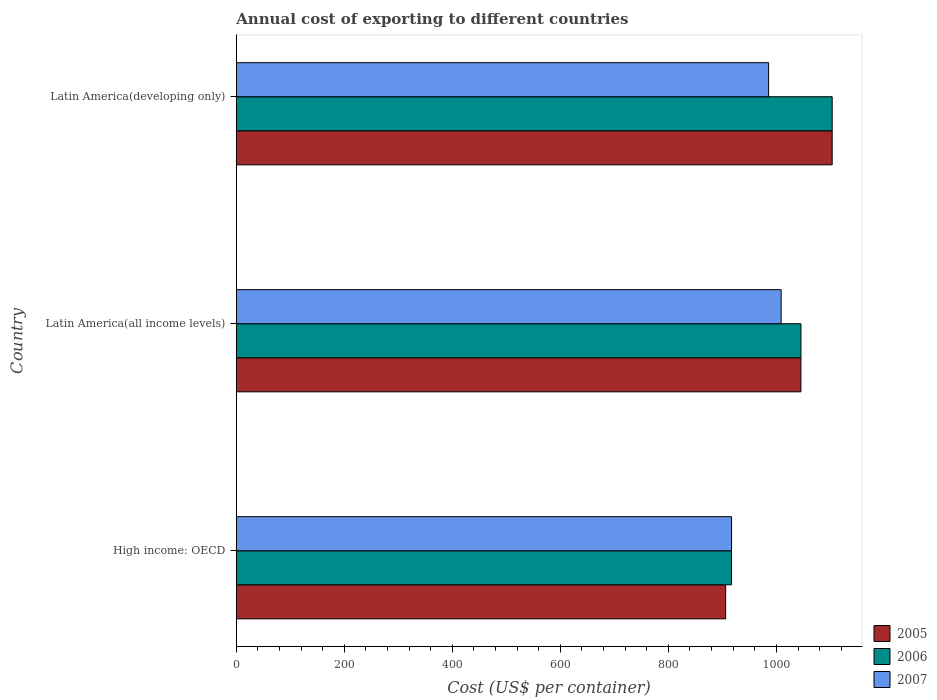Are the number of bars per tick equal to the number of legend labels?
Your answer should be compact. Yes. Are the number of bars on each tick of the Y-axis equal?
Provide a succinct answer. Yes. How many bars are there on the 2nd tick from the bottom?
Keep it short and to the point. 3. What is the label of the 2nd group of bars from the top?
Offer a terse response. Latin America(all income levels). What is the total annual cost of exporting in 2005 in High income: OECD?
Make the answer very short. 906.03. Across all countries, what is the maximum total annual cost of exporting in 2006?
Make the answer very short. 1103.3. Across all countries, what is the minimum total annual cost of exporting in 2007?
Your answer should be very brief. 916.94. In which country was the total annual cost of exporting in 2007 maximum?
Offer a terse response. Latin America(all income levels). In which country was the total annual cost of exporting in 2007 minimum?
Offer a very short reply. High income: OECD. What is the total total annual cost of exporting in 2005 in the graph?
Provide a succinct answer. 3054.71. What is the difference between the total annual cost of exporting in 2007 in High income: OECD and that in Latin America(all income levels)?
Your response must be concise. -91.88. What is the difference between the total annual cost of exporting in 2007 in High income: OECD and the total annual cost of exporting in 2006 in Latin America(developing only)?
Provide a short and direct response. -186.37. What is the average total annual cost of exporting in 2005 per country?
Your answer should be very brief. 1018.24. What is the difference between the total annual cost of exporting in 2007 and total annual cost of exporting in 2006 in Latin America(developing only)?
Offer a terse response. -117.7. What is the ratio of the total annual cost of exporting in 2005 in High income: OECD to that in Latin America(all income levels)?
Your answer should be very brief. 0.87. Is the difference between the total annual cost of exporting in 2007 in High income: OECD and Latin America(developing only) greater than the difference between the total annual cost of exporting in 2006 in High income: OECD and Latin America(developing only)?
Your answer should be very brief. Yes. What is the difference between the highest and the second highest total annual cost of exporting in 2007?
Your answer should be compact. 23.2. What is the difference between the highest and the lowest total annual cost of exporting in 2005?
Keep it short and to the point. 197.23. Is the sum of the total annual cost of exporting in 2007 in High income: OECD and Latin America(developing only) greater than the maximum total annual cost of exporting in 2006 across all countries?
Make the answer very short. Yes. Are all the bars in the graph horizontal?
Offer a very short reply. Yes. Does the graph contain grids?
Your answer should be very brief. No. Where does the legend appear in the graph?
Your answer should be compact. Bottom right. How are the legend labels stacked?
Your response must be concise. Vertical. What is the title of the graph?
Your answer should be very brief. Annual cost of exporting to different countries. Does "1969" appear as one of the legend labels in the graph?
Provide a short and direct response. No. What is the label or title of the X-axis?
Your answer should be very brief. Cost (US$ per container). What is the Cost (US$ per container) of 2005 in High income: OECD?
Provide a short and direct response. 906.03. What is the Cost (US$ per container) of 2006 in High income: OECD?
Provide a short and direct response. 916.78. What is the Cost (US$ per container) in 2007 in High income: OECD?
Make the answer very short. 916.94. What is the Cost (US$ per container) of 2005 in Latin America(all income levels)?
Offer a terse response. 1045.42. What is the Cost (US$ per container) in 2006 in Latin America(all income levels)?
Make the answer very short. 1045.45. What is the Cost (US$ per container) of 2007 in Latin America(all income levels)?
Ensure brevity in your answer.  1008.81. What is the Cost (US$ per container) of 2005 in Latin America(developing only)?
Give a very brief answer. 1103.26. What is the Cost (US$ per container) of 2006 in Latin America(developing only)?
Your answer should be very brief. 1103.3. What is the Cost (US$ per container) of 2007 in Latin America(developing only)?
Ensure brevity in your answer.  985.61. Across all countries, what is the maximum Cost (US$ per container) of 2005?
Make the answer very short. 1103.26. Across all countries, what is the maximum Cost (US$ per container) in 2006?
Your response must be concise. 1103.3. Across all countries, what is the maximum Cost (US$ per container) of 2007?
Provide a short and direct response. 1008.81. Across all countries, what is the minimum Cost (US$ per container) of 2005?
Ensure brevity in your answer.  906.03. Across all countries, what is the minimum Cost (US$ per container) of 2006?
Make the answer very short. 916.78. Across all countries, what is the minimum Cost (US$ per container) in 2007?
Offer a very short reply. 916.94. What is the total Cost (US$ per container) of 2005 in the graph?
Ensure brevity in your answer.  3054.71. What is the total Cost (US$ per container) in 2006 in the graph?
Your answer should be very brief. 3065.54. What is the total Cost (US$ per container) of 2007 in the graph?
Ensure brevity in your answer.  2911.36. What is the difference between the Cost (US$ per container) in 2005 in High income: OECD and that in Latin America(all income levels)?
Provide a short and direct response. -139.39. What is the difference between the Cost (US$ per container) of 2006 in High income: OECD and that in Latin America(all income levels)?
Keep it short and to the point. -128.67. What is the difference between the Cost (US$ per container) in 2007 in High income: OECD and that in Latin America(all income levels)?
Offer a very short reply. -91.88. What is the difference between the Cost (US$ per container) in 2005 in High income: OECD and that in Latin America(developing only)?
Your answer should be compact. -197.23. What is the difference between the Cost (US$ per container) in 2006 in High income: OECD and that in Latin America(developing only)?
Offer a very short reply. -186.52. What is the difference between the Cost (US$ per container) in 2007 in High income: OECD and that in Latin America(developing only)?
Keep it short and to the point. -68.67. What is the difference between the Cost (US$ per container) in 2005 in Latin America(all income levels) and that in Latin America(developing only)?
Your answer should be compact. -57.84. What is the difference between the Cost (US$ per container) of 2006 in Latin America(all income levels) and that in Latin America(developing only)?
Your answer should be very brief. -57.85. What is the difference between the Cost (US$ per container) of 2007 in Latin America(all income levels) and that in Latin America(developing only)?
Make the answer very short. 23.2. What is the difference between the Cost (US$ per container) of 2005 in High income: OECD and the Cost (US$ per container) of 2006 in Latin America(all income levels)?
Give a very brief answer. -139.42. What is the difference between the Cost (US$ per container) of 2005 in High income: OECD and the Cost (US$ per container) of 2007 in Latin America(all income levels)?
Offer a terse response. -102.78. What is the difference between the Cost (US$ per container) in 2006 in High income: OECD and the Cost (US$ per container) in 2007 in Latin America(all income levels)?
Offer a terse response. -92.03. What is the difference between the Cost (US$ per container) of 2005 in High income: OECD and the Cost (US$ per container) of 2006 in Latin America(developing only)?
Your response must be concise. -197.27. What is the difference between the Cost (US$ per container) of 2005 in High income: OECD and the Cost (US$ per container) of 2007 in Latin America(developing only)?
Your response must be concise. -79.58. What is the difference between the Cost (US$ per container) in 2006 in High income: OECD and the Cost (US$ per container) in 2007 in Latin America(developing only)?
Your answer should be very brief. -68.83. What is the difference between the Cost (US$ per container) in 2005 in Latin America(all income levels) and the Cost (US$ per container) in 2006 in Latin America(developing only)?
Your answer should be very brief. -57.88. What is the difference between the Cost (US$ per container) of 2005 in Latin America(all income levels) and the Cost (US$ per container) of 2007 in Latin America(developing only)?
Provide a succinct answer. 59.81. What is the difference between the Cost (US$ per container) in 2006 in Latin America(all income levels) and the Cost (US$ per container) in 2007 in Latin America(developing only)?
Your answer should be very brief. 59.84. What is the average Cost (US$ per container) in 2005 per country?
Offer a terse response. 1018.24. What is the average Cost (US$ per container) of 2006 per country?
Your response must be concise. 1021.85. What is the average Cost (US$ per container) in 2007 per country?
Give a very brief answer. 970.45. What is the difference between the Cost (US$ per container) in 2005 and Cost (US$ per container) in 2006 in High income: OECD?
Give a very brief answer. -10.75. What is the difference between the Cost (US$ per container) in 2005 and Cost (US$ per container) in 2007 in High income: OECD?
Ensure brevity in your answer.  -10.91. What is the difference between the Cost (US$ per container) in 2006 and Cost (US$ per container) in 2007 in High income: OECD?
Give a very brief answer. -0.16. What is the difference between the Cost (US$ per container) in 2005 and Cost (US$ per container) in 2006 in Latin America(all income levels)?
Ensure brevity in your answer.  -0.03. What is the difference between the Cost (US$ per container) in 2005 and Cost (US$ per container) in 2007 in Latin America(all income levels)?
Offer a very short reply. 36.61. What is the difference between the Cost (US$ per container) of 2006 and Cost (US$ per container) of 2007 in Latin America(all income levels)?
Provide a short and direct response. 36.64. What is the difference between the Cost (US$ per container) of 2005 and Cost (US$ per container) of 2006 in Latin America(developing only)?
Make the answer very short. -0.04. What is the difference between the Cost (US$ per container) in 2005 and Cost (US$ per container) in 2007 in Latin America(developing only)?
Keep it short and to the point. 117.65. What is the difference between the Cost (US$ per container) in 2006 and Cost (US$ per container) in 2007 in Latin America(developing only)?
Provide a short and direct response. 117.7. What is the ratio of the Cost (US$ per container) of 2005 in High income: OECD to that in Latin America(all income levels)?
Offer a very short reply. 0.87. What is the ratio of the Cost (US$ per container) of 2006 in High income: OECD to that in Latin America(all income levels)?
Your response must be concise. 0.88. What is the ratio of the Cost (US$ per container) in 2007 in High income: OECD to that in Latin America(all income levels)?
Offer a terse response. 0.91. What is the ratio of the Cost (US$ per container) in 2005 in High income: OECD to that in Latin America(developing only)?
Offer a very short reply. 0.82. What is the ratio of the Cost (US$ per container) of 2006 in High income: OECD to that in Latin America(developing only)?
Offer a very short reply. 0.83. What is the ratio of the Cost (US$ per container) of 2007 in High income: OECD to that in Latin America(developing only)?
Keep it short and to the point. 0.93. What is the ratio of the Cost (US$ per container) in 2005 in Latin America(all income levels) to that in Latin America(developing only)?
Offer a very short reply. 0.95. What is the ratio of the Cost (US$ per container) of 2006 in Latin America(all income levels) to that in Latin America(developing only)?
Provide a short and direct response. 0.95. What is the ratio of the Cost (US$ per container) of 2007 in Latin America(all income levels) to that in Latin America(developing only)?
Keep it short and to the point. 1.02. What is the difference between the highest and the second highest Cost (US$ per container) of 2005?
Offer a very short reply. 57.84. What is the difference between the highest and the second highest Cost (US$ per container) in 2006?
Offer a terse response. 57.85. What is the difference between the highest and the second highest Cost (US$ per container) in 2007?
Offer a terse response. 23.2. What is the difference between the highest and the lowest Cost (US$ per container) of 2005?
Make the answer very short. 197.23. What is the difference between the highest and the lowest Cost (US$ per container) of 2006?
Provide a succinct answer. 186.52. What is the difference between the highest and the lowest Cost (US$ per container) in 2007?
Offer a very short reply. 91.88. 